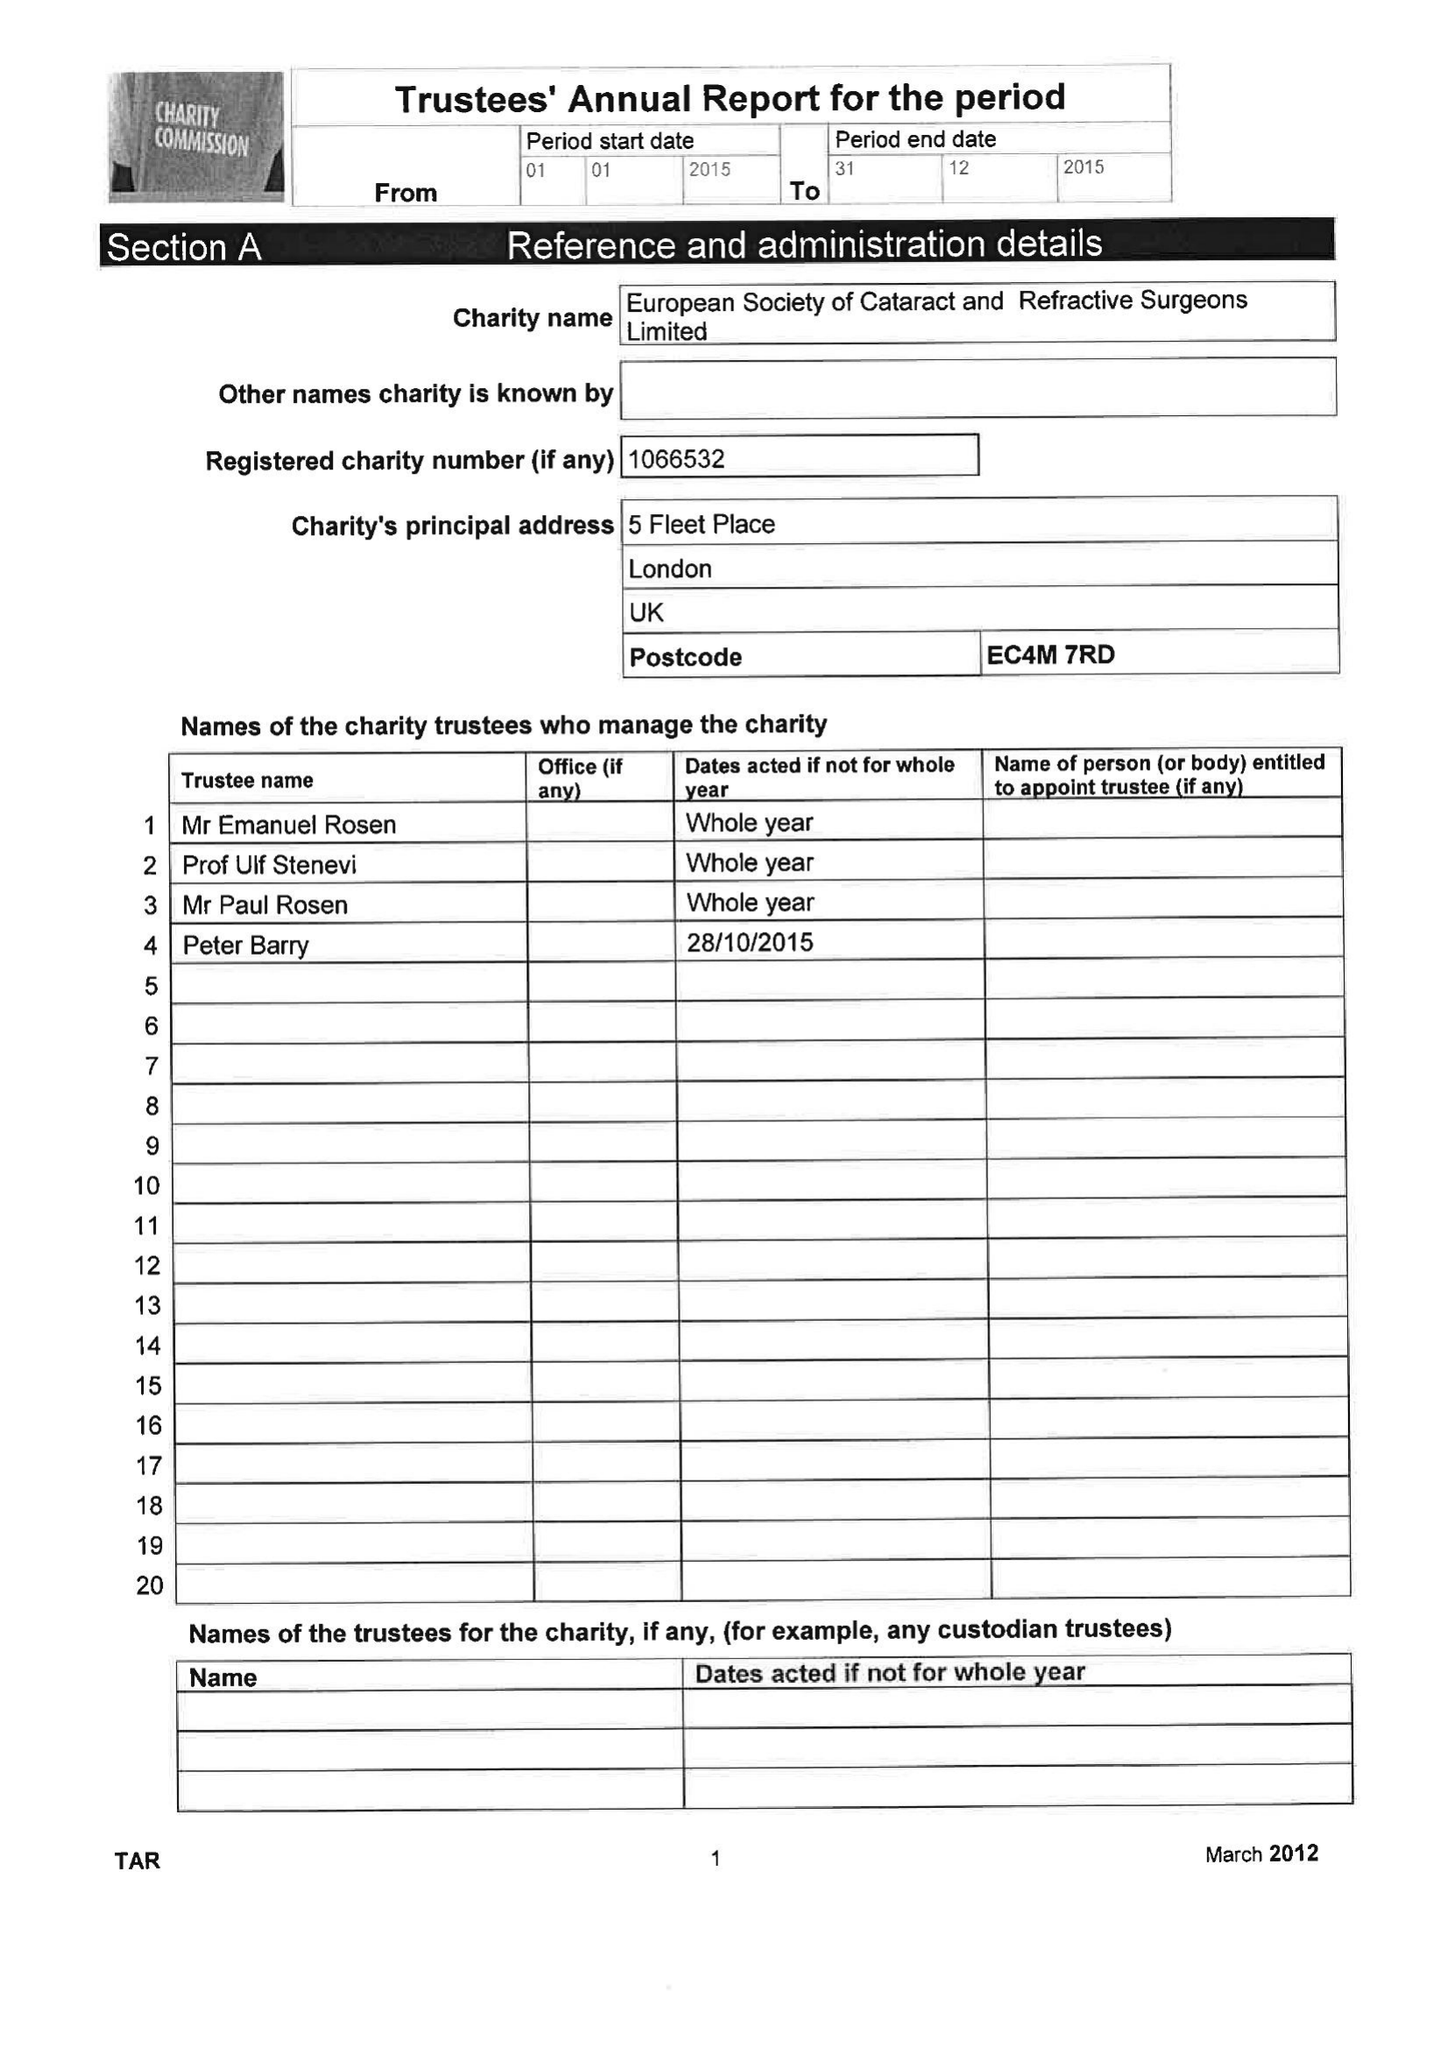What is the value for the charity_name?
Answer the question using a single word or phrase. European Society Of Cataract and Refractive Surgeons Ltd. 